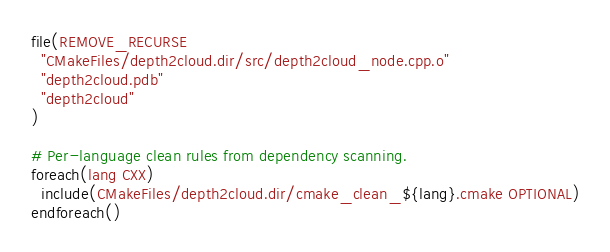Convert code to text. <code><loc_0><loc_0><loc_500><loc_500><_CMake_>file(REMOVE_RECURSE
  "CMakeFiles/depth2cloud.dir/src/depth2cloud_node.cpp.o"
  "depth2cloud.pdb"
  "depth2cloud"
)

# Per-language clean rules from dependency scanning.
foreach(lang CXX)
  include(CMakeFiles/depth2cloud.dir/cmake_clean_${lang}.cmake OPTIONAL)
endforeach()
</code> 